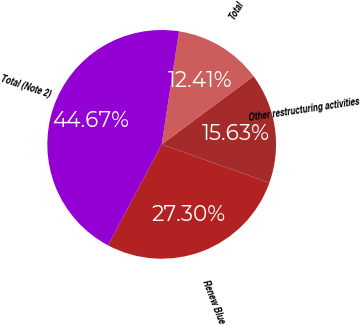Convert chart to OTSL. <chart><loc_0><loc_0><loc_500><loc_500><pie_chart><fcel>Renew Blue<fcel>Other restructuring activities<fcel>Total<fcel>Total (Note 2)<nl><fcel>27.3%<fcel>15.63%<fcel>12.41%<fcel>44.67%<nl></chart> 